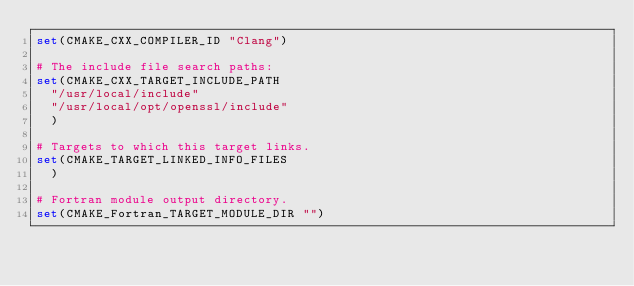<code> <loc_0><loc_0><loc_500><loc_500><_CMake_>set(CMAKE_CXX_COMPILER_ID "Clang")

# The include file search paths:
set(CMAKE_CXX_TARGET_INCLUDE_PATH
  "/usr/local/include"
  "/usr/local/opt/openssl/include"
  )

# Targets to which this target links.
set(CMAKE_TARGET_LINKED_INFO_FILES
  )

# Fortran module output directory.
set(CMAKE_Fortran_TARGET_MODULE_DIR "")
</code> 